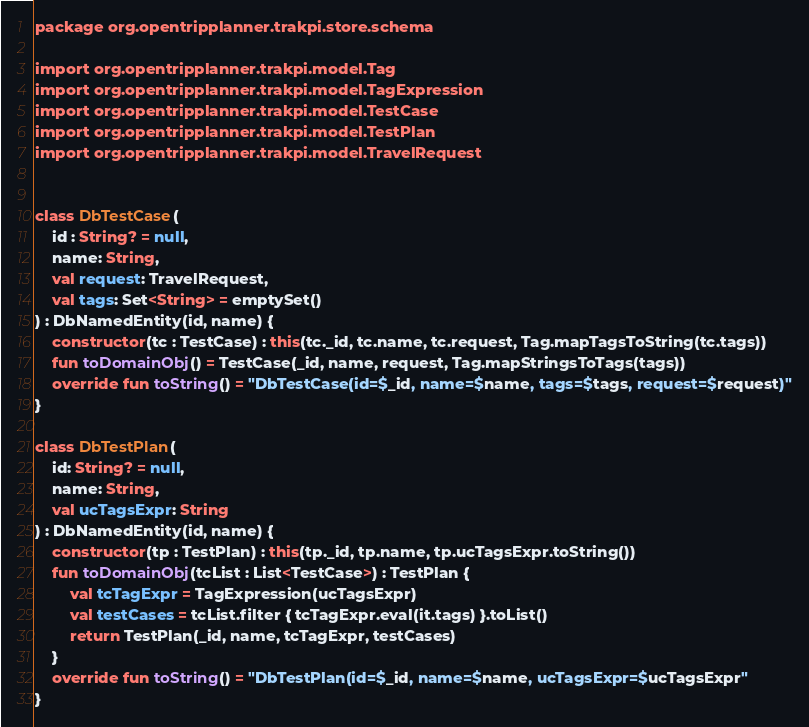<code> <loc_0><loc_0><loc_500><loc_500><_Kotlin_>package org.opentripplanner.trakpi.store.schema

import org.opentripplanner.trakpi.model.Tag
import org.opentripplanner.trakpi.model.TagExpression
import org.opentripplanner.trakpi.model.TestCase
import org.opentripplanner.trakpi.model.TestPlan
import org.opentripplanner.trakpi.model.TravelRequest


class DbTestCase(
    id : String? = null,
    name: String,
    val request: TravelRequest,
    val tags: Set<String> = emptySet()
) : DbNamedEntity(id, name) {
    constructor(tc : TestCase) : this(tc._id, tc.name, tc.request, Tag.mapTagsToString(tc.tags))
    fun toDomainObj() = TestCase(_id, name, request, Tag.mapStringsToTags(tags))
    override fun toString() = "DbTestCase(id=$_id, name=$name, tags=$tags, request=$request)"
}

class DbTestPlan(
    id: String? = null,
    name: String,
    val ucTagsExpr: String
) : DbNamedEntity(id, name) {
    constructor(tp : TestPlan) : this(tp._id, tp.name, tp.ucTagsExpr.toString())
    fun toDomainObj(tcList : List<TestCase>) : TestPlan {
        val tcTagExpr = TagExpression(ucTagsExpr)
        val testCases = tcList.filter { tcTagExpr.eval(it.tags) }.toList()
        return TestPlan(_id, name, tcTagExpr, testCases)
    }
    override fun toString() = "DbTestPlan(id=$_id, name=$name, ucTagsExpr=$ucTagsExpr"
}
</code> 